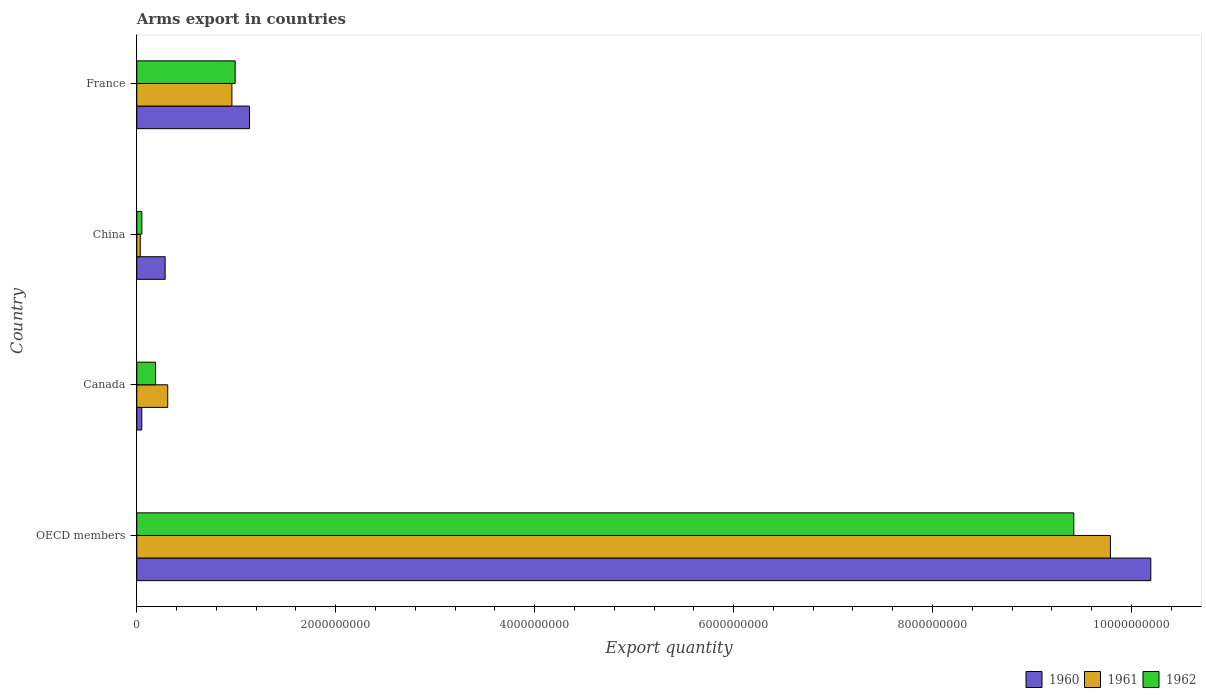How many different coloured bars are there?
Give a very brief answer. 3. How many bars are there on the 1st tick from the top?
Ensure brevity in your answer.  3. What is the label of the 4th group of bars from the top?
Keep it short and to the point. OECD members. What is the total arms export in 1961 in OECD members?
Your answer should be compact. 9.79e+09. Across all countries, what is the maximum total arms export in 1961?
Keep it short and to the point. 9.79e+09. Across all countries, what is the minimum total arms export in 1960?
Keep it short and to the point. 5.00e+07. In which country was the total arms export in 1961 minimum?
Offer a very short reply. China. What is the total total arms export in 1961 in the graph?
Keep it short and to the point. 1.11e+1. What is the difference between the total arms export in 1961 in Canada and that in France?
Keep it short and to the point. -6.45e+08. What is the difference between the total arms export in 1962 in China and the total arms export in 1960 in France?
Offer a very short reply. -1.08e+09. What is the average total arms export in 1960 per country?
Keep it short and to the point. 2.92e+09. What is the difference between the total arms export in 1961 and total arms export in 1962 in OECD members?
Give a very brief answer. 3.68e+08. What is the ratio of the total arms export in 1961 in Canada to that in France?
Offer a terse response. 0.33. Is the total arms export in 1961 in China less than that in OECD members?
Offer a very short reply. Yes. Is the difference between the total arms export in 1961 in Canada and OECD members greater than the difference between the total arms export in 1962 in Canada and OECD members?
Your response must be concise. No. What is the difference between the highest and the second highest total arms export in 1961?
Your response must be concise. 8.83e+09. What is the difference between the highest and the lowest total arms export in 1960?
Provide a succinct answer. 1.01e+1. Is the sum of the total arms export in 1961 in France and OECD members greater than the maximum total arms export in 1960 across all countries?
Your response must be concise. Yes. What does the 3rd bar from the bottom in Canada represents?
Provide a succinct answer. 1962. Is it the case that in every country, the sum of the total arms export in 1962 and total arms export in 1961 is greater than the total arms export in 1960?
Your answer should be compact. No. How many bars are there?
Provide a short and direct response. 12. What is the difference between two consecutive major ticks on the X-axis?
Your answer should be very brief. 2.00e+09. Are the values on the major ticks of X-axis written in scientific E-notation?
Provide a short and direct response. No. Does the graph contain grids?
Your answer should be very brief. No. How many legend labels are there?
Provide a short and direct response. 3. What is the title of the graph?
Make the answer very short. Arms export in countries. What is the label or title of the X-axis?
Offer a very short reply. Export quantity. What is the label or title of the Y-axis?
Your answer should be very brief. Country. What is the Export quantity of 1960 in OECD members?
Your answer should be very brief. 1.02e+1. What is the Export quantity in 1961 in OECD members?
Offer a very short reply. 9.79e+09. What is the Export quantity in 1962 in OECD members?
Offer a very short reply. 9.42e+09. What is the Export quantity in 1961 in Canada?
Provide a short and direct response. 3.11e+08. What is the Export quantity of 1962 in Canada?
Make the answer very short. 1.88e+08. What is the Export quantity of 1960 in China?
Your response must be concise. 2.85e+08. What is the Export quantity in 1961 in China?
Offer a terse response. 3.50e+07. What is the Export quantity in 1962 in China?
Provide a short and direct response. 5.10e+07. What is the Export quantity of 1960 in France?
Make the answer very short. 1.13e+09. What is the Export quantity of 1961 in France?
Keep it short and to the point. 9.56e+08. What is the Export quantity of 1962 in France?
Provide a succinct answer. 9.89e+08. Across all countries, what is the maximum Export quantity in 1960?
Provide a short and direct response. 1.02e+1. Across all countries, what is the maximum Export quantity of 1961?
Offer a very short reply. 9.79e+09. Across all countries, what is the maximum Export quantity in 1962?
Provide a succinct answer. 9.42e+09. Across all countries, what is the minimum Export quantity of 1961?
Ensure brevity in your answer.  3.50e+07. Across all countries, what is the minimum Export quantity of 1962?
Your answer should be compact. 5.10e+07. What is the total Export quantity in 1960 in the graph?
Provide a short and direct response. 1.17e+1. What is the total Export quantity of 1961 in the graph?
Make the answer very short. 1.11e+1. What is the total Export quantity in 1962 in the graph?
Provide a succinct answer. 1.06e+1. What is the difference between the Export quantity in 1960 in OECD members and that in Canada?
Ensure brevity in your answer.  1.01e+1. What is the difference between the Export quantity in 1961 in OECD members and that in Canada?
Offer a terse response. 9.48e+09. What is the difference between the Export quantity in 1962 in OECD members and that in Canada?
Your answer should be compact. 9.23e+09. What is the difference between the Export quantity of 1960 in OECD members and that in China?
Your answer should be very brief. 9.91e+09. What is the difference between the Export quantity of 1961 in OECD members and that in China?
Offer a terse response. 9.75e+09. What is the difference between the Export quantity of 1962 in OECD members and that in China?
Provide a short and direct response. 9.37e+09. What is the difference between the Export quantity of 1960 in OECD members and that in France?
Your response must be concise. 9.06e+09. What is the difference between the Export quantity of 1961 in OECD members and that in France?
Your response must be concise. 8.83e+09. What is the difference between the Export quantity in 1962 in OECD members and that in France?
Offer a very short reply. 8.43e+09. What is the difference between the Export quantity of 1960 in Canada and that in China?
Your answer should be compact. -2.35e+08. What is the difference between the Export quantity in 1961 in Canada and that in China?
Ensure brevity in your answer.  2.76e+08. What is the difference between the Export quantity in 1962 in Canada and that in China?
Your response must be concise. 1.37e+08. What is the difference between the Export quantity of 1960 in Canada and that in France?
Give a very brief answer. -1.08e+09. What is the difference between the Export quantity of 1961 in Canada and that in France?
Provide a short and direct response. -6.45e+08. What is the difference between the Export quantity of 1962 in Canada and that in France?
Offer a terse response. -8.01e+08. What is the difference between the Export quantity in 1960 in China and that in France?
Give a very brief answer. -8.48e+08. What is the difference between the Export quantity of 1961 in China and that in France?
Offer a terse response. -9.21e+08. What is the difference between the Export quantity of 1962 in China and that in France?
Your answer should be compact. -9.38e+08. What is the difference between the Export quantity in 1960 in OECD members and the Export quantity in 1961 in Canada?
Your answer should be compact. 9.88e+09. What is the difference between the Export quantity in 1960 in OECD members and the Export quantity in 1962 in Canada?
Ensure brevity in your answer.  1.00e+1. What is the difference between the Export quantity in 1961 in OECD members and the Export quantity in 1962 in Canada?
Keep it short and to the point. 9.60e+09. What is the difference between the Export quantity in 1960 in OECD members and the Export quantity in 1961 in China?
Provide a short and direct response. 1.02e+1. What is the difference between the Export quantity in 1960 in OECD members and the Export quantity in 1962 in China?
Your answer should be very brief. 1.01e+1. What is the difference between the Export quantity of 1961 in OECD members and the Export quantity of 1962 in China?
Ensure brevity in your answer.  9.74e+09. What is the difference between the Export quantity of 1960 in OECD members and the Export quantity of 1961 in France?
Keep it short and to the point. 9.24e+09. What is the difference between the Export quantity of 1960 in OECD members and the Export quantity of 1962 in France?
Provide a short and direct response. 9.20e+09. What is the difference between the Export quantity of 1961 in OECD members and the Export quantity of 1962 in France?
Provide a succinct answer. 8.80e+09. What is the difference between the Export quantity in 1960 in Canada and the Export quantity in 1961 in China?
Your response must be concise. 1.50e+07. What is the difference between the Export quantity in 1960 in Canada and the Export quantity in 1962 in China?
Ensure brevity in your answer.  -1.00e+06. What is the difference between the Export quantity in 1961 in Canada and the Export quantity in 1962 in China?
Offer a terse response. 2.60e+08. What is the difference between the Export quantity of 1960 in Canada and the Export quantity of 1961 in France?
Make the answer very short. -9.06e+08. What is the difference between the Export quantity of 1960 in Canada and the Export quantity of 1962 in France?
Give a very brief answer. -9.39e+08. What is the difference between the Export quantity of 1961 in Canada and the Export quantity of 1962 in France?
Make the answer very short. -6.78e+08. What is the difference between the Export quantity in 1960 in China and the Export quantity in 1961 in France?
Your answer should be very brief. -6.71e+08. What is the difference between the Export quantity in 1960 in China and the Export quantity in 1962 in France?
Make the answer very short. -7.04e+08. What is the difference between the Export quantity in 1961 in China and the Export quantity in 1962 in France?
Offer a very short reply. -9.54e+08. What is the average Export quantity in 1960 per country?
Offer a very short reply. 2.92e+09. What is the average Export quantity in 1961 per country?
Your answer should be very brief. 2.77e+09. What is the average Export quantity of 1962 per country?
Your answer should be very brief. 2.66e+09. What is the difference between the Export quantity of 1960 and Export quantity of 1961 in OECD members?
Provide a short and direct response. 4.06e+08. What is the difference between the Export quantity of 1960 and Export quantity of 1962 in OECD members?
Offer a terse response. 7.74e+08. What is the difference between the Export quantity in 1961 and Export quantity in 1962 in OECD members?
Provide a short and direct response. 3.68e+08. What is the difference between the Export quantity in 1960 and Export quantity in 1961 in Canada?
Give a very brief answer. -2.61e+08. What is the difference between the Export quantity in 1960 and Export quantity in 1962 in Canada?
Your answer should be very brief. -1.38e+08. What is the difference between the Export quantity of 1961 and Export quantity of 1962 in Canada?
Ensure brevity in your answer.  1.23e+08. What is the difference between the Export quantity in 1960 and Export quantity in 1961 in China?
Offer a very short reply. 2.50e+08. What is the difference between the Export quantity of 1960 and Export quantity of 1962 in China?
Keep it short and to the point. 2.34e+08. What is the difference between the Export quantity in 1961 and Export quantity in 1962 in China?
Provide a succinct answer. -1.60e+07. What is the difference between the Export quantity of 1960 and Export quantity of 1961 in France?
Provide a short and direct response. 1.77e+08. What is the difference between the Export quantity in 1960 and Export quantity in 1962 in France?
Give a very brief answer. 1.44e+08. What is the difference between the Export quantity in 1961 and Export quantity in 1962 in France?
Offer a terse response. -3.30e+07. What is the ratio of the Export quantity of 1960 in OECD members to that in Canada?
Ensure brevity in your answer.  203.88. What is the ratio of the Export quantity of 1961 in OECD members to that in Canada?
Keep it short and to the point. 31.47. What is the ratio of the Export quantity in 1962 in OECD members to that in Canada?
Your answer should be very brief. 50.11. What is the ratio of the Export quantity of 1960 in OECD members to that in China?
Ensure brevity in your answer.  35.77. What is the ratio of the Export quantity of 1961 in OECD members to that in China?
Give a very brief answer. 279.66. What is the ratio of the Export quantity in 1962 in OECD members to that in China?
Offer a very short reply. 184.71. What is the ratio of the Export quantity of 1960 in OECD members to that in France?
Offer a terse response. 9. What is the ratio of the Export quantity in 1961 in OECD members to that in France?
Offer a very short reply. 10.24. What is the ratio of the Export quantity in 1962 in OECD members to that in France?
Make the answer very short. 9.52. What is the ratio of the Export quantity in 1960 in Canada to that in China?
Make the answer very short. 0.18. What is the ratio of the Export quantity in 1961 in Canada to that in China?
Give a very brief answer. 8.89. What is the ratio of the Export quantity in 1962 in Canada to that in China?
Keep it short and to the point. 3.69. What is the ratio of the Export quantity in 1960 in Canada to that in France?
Keep it short and to the point. 0.04. What is the ratio of the Export quantity of 1961 in Canada to that in France?
Provide a short and direct response. 0.33. What is the ratio of the Export quantity of 1962 in Canada to that in France?
Provide a short and direct response. 0.19. What is the ratio of the Export quantity in 1960 in China to that in France?
Give a very brief answer. 0.25. What is the ratio of the Export quantity in 1961 in China to that in France?
Offer a terse response. 0.04. What is the ratio of the Export quantity of 1962 in China to that in France?
Ensure brevity in your answer.  0.05. What is the difference between the highest and the second highest Export quantity of 1960?
Give a very brief answer. 9.06e+09. What is the difference between the highest and the second highest Export quantity in 1961?
Offer a very short reply. 8.83e+09. What is the difference between the highest and the second highest Export quantity of 1962?
Provide a succinct answer. 8.43e+09. What is the difference between the highest and the lowest Export quantity in 1960?
Provide a succinct answer. 1.01e+1. What is the difference between the highest and the lowest Export quantity in 1961?
Your response must be concise. 9.75e+09. What is the difference between the highest and the lowest Export quantity of 1962?
Make the answer very short. 9.37e+09. 